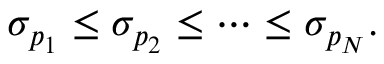Convert formula to latex. <formula><loc_0><loc_0><loc_500><loc_500>\sigma _ { p _ { 1 } } \leq \sigma _ { p _ { 2 } } \leq \cdots \leq \sigma _ { p _ { N } } .</formula> 